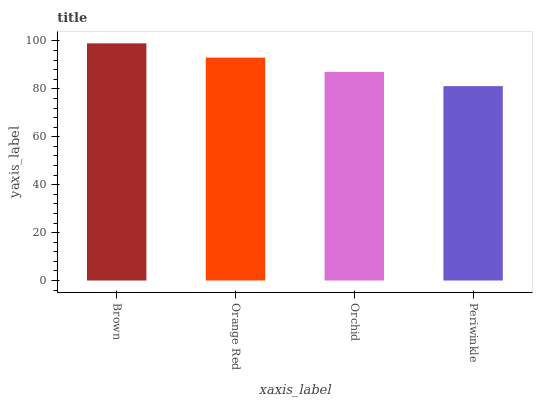Is Periwinkle the minimum?
Answer yes or no. Yes. Is Brown the maximum?
Answer yes or no. Yes. Is Orange Red the minimum?
Answer yes or no. No. Is Orange Red the maximum?
Answer yes or no. No. Is Brown greater than Orange Red?
Answer yes or no. Yes. Is Orange Red less than Brown?
Answer yes or no. Yes. Is Orange Red greater than Brown?
Answer yes or no. No. Is Brown less than Orange Red?
Answer yes or no. No. Is Orange Red the high median?
Answer yes or no. Yes. Is Orchid the low median?
Answer yes or no. Yes. Is Periwinkle the high median?
Answer yes or no. No. Is Orange Red the low median?
Answer yes or no. No. 